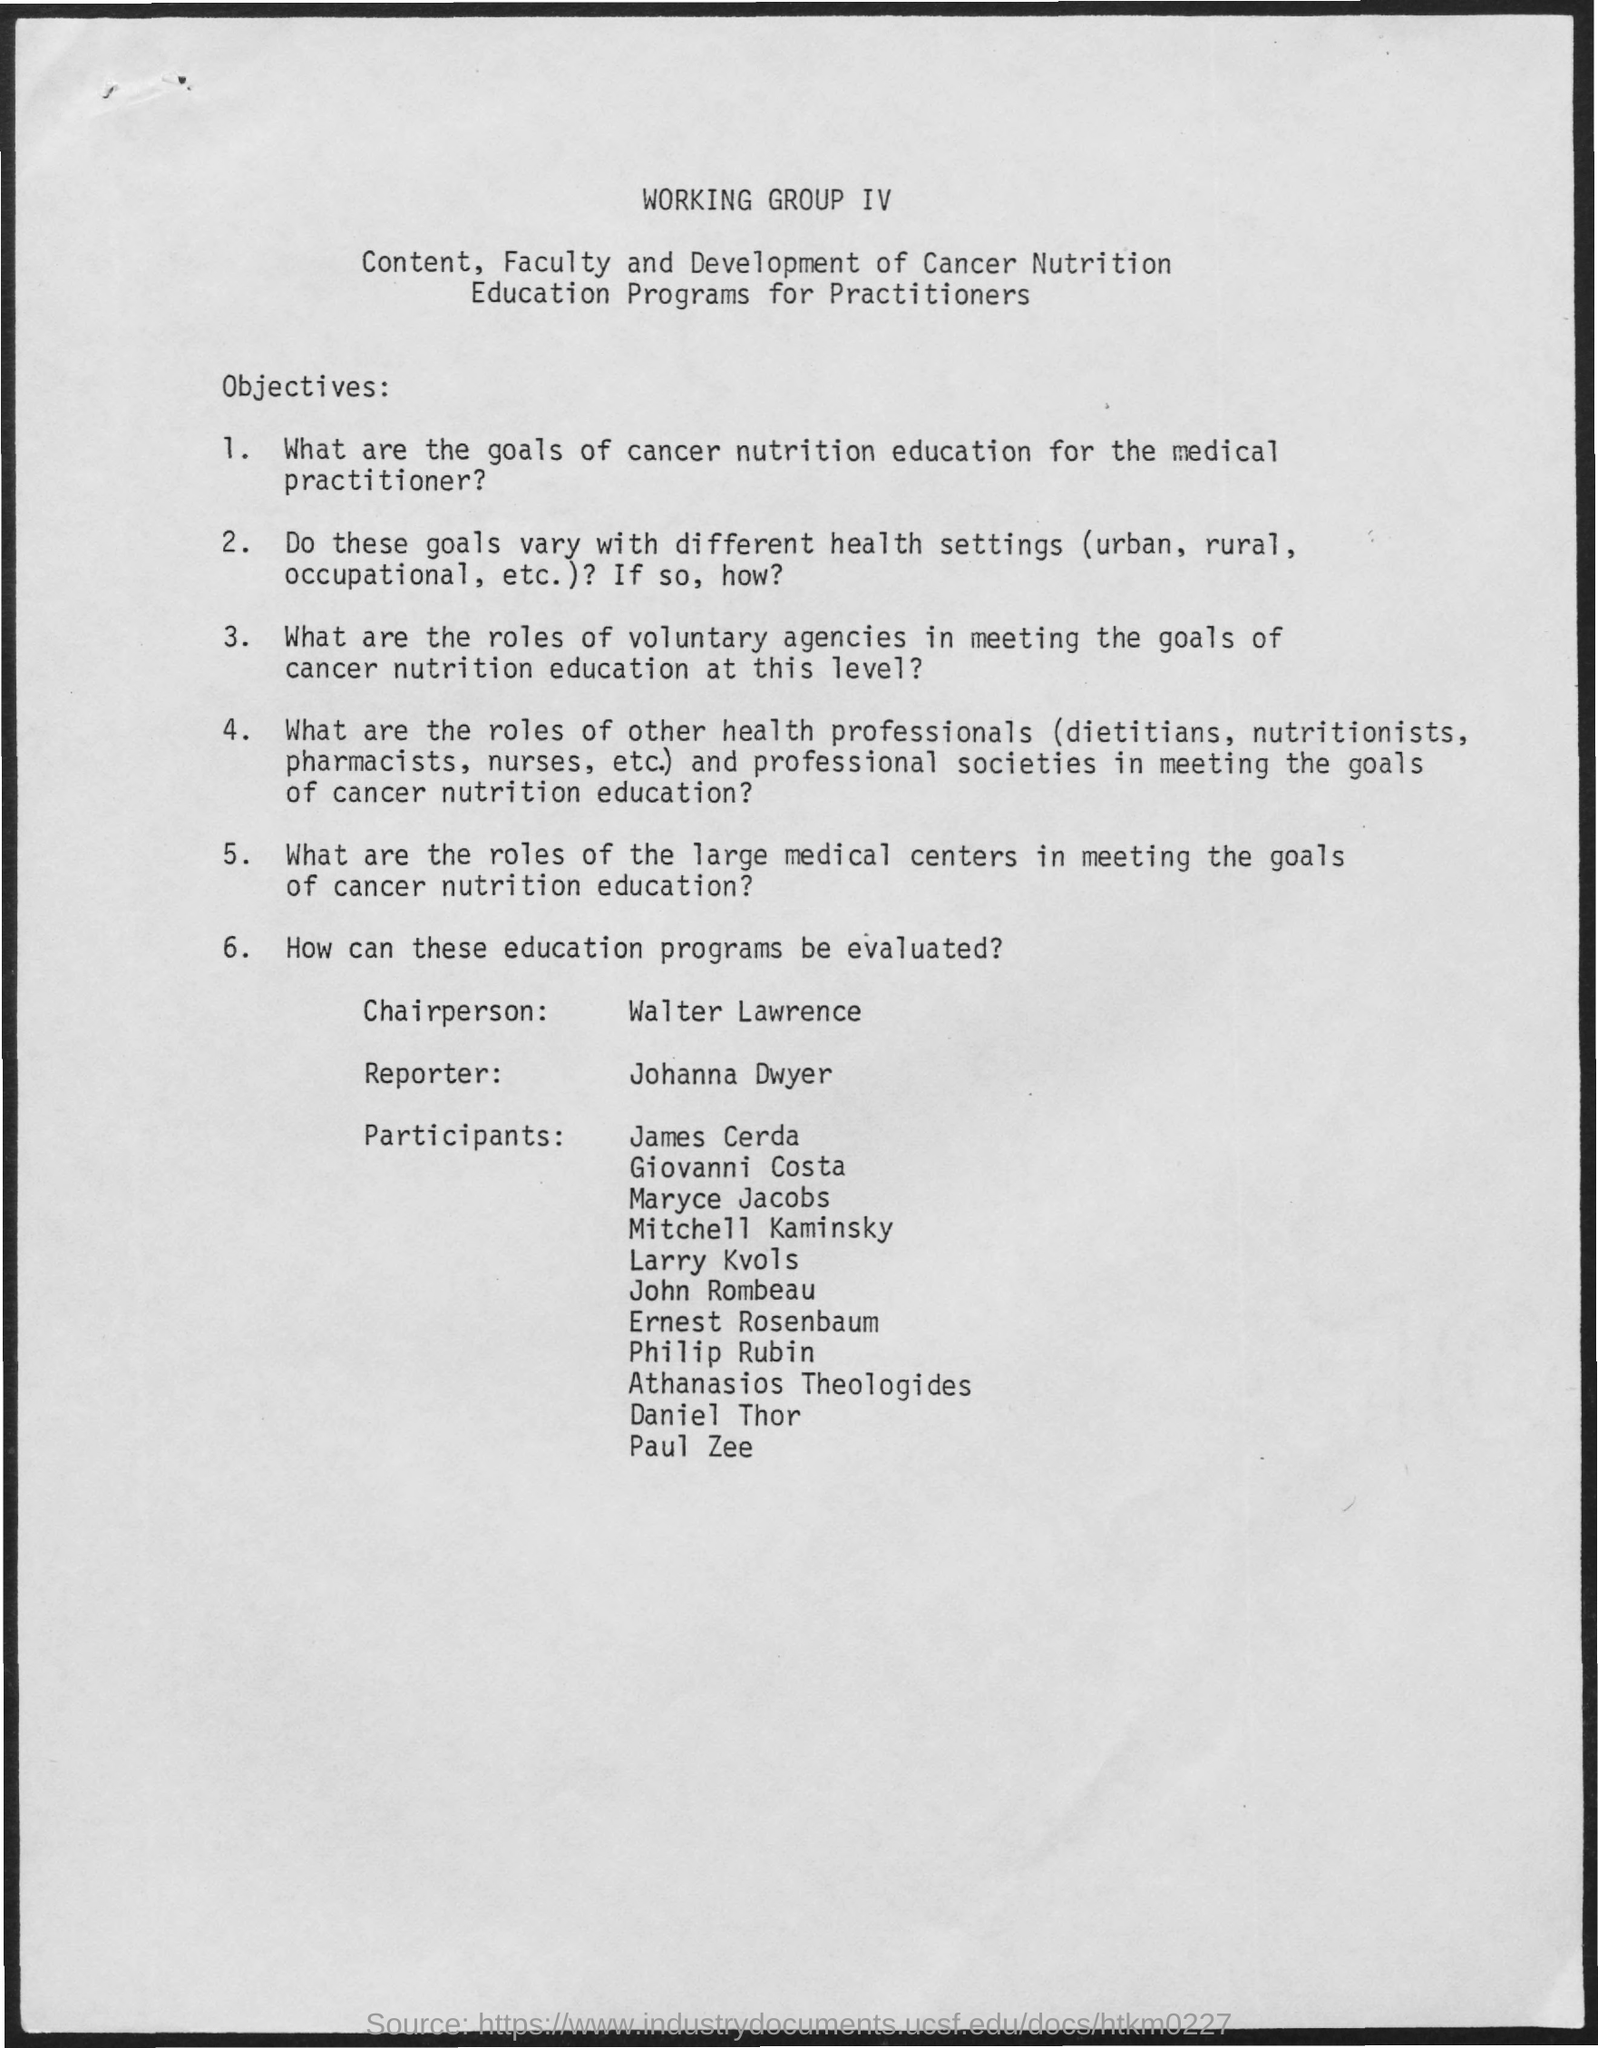what is the name of the chairperson mentioned in the given page ? The chairperson mentioned on the document is Walter Lawrence. He appears to be leading a group focused on 'Content, Faculty and Development of Cancer Nutrition Education Programs for Practitioners', which underscores the importance of nutritional education in cancer treatment and care for medical practitioners. 